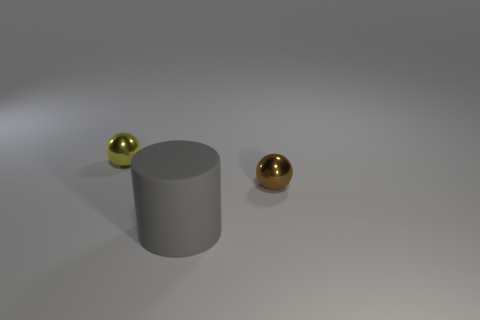There is a tiny thing that is behind the tiny brown metal sphere; what is its shape?
Give a very brief answer. Sphere. There is a tiny thing behind the tiny brown object; does it have the same shape as the large matte thing?
Your response must be concise. No. What number of things are either small things right of the yellow sphere or tiny matte cylinders?
Your response must be concise. 1. There is another tiny metal thing that is the same shape as the small yellow object; what is its color?
Keep it short and to the point. Brown. Are there any other things that have the same color as the big cylinder?
Give a very brief answer. No. There is a metal thing that is to the left of the small brown metal sphere; how big is it?
Provide a short and direct response. Small. Do the cylinder and the thing left of the cylinder have the same color?
Keep it short and to the point. No. What number of other objects are the same material as the brown sphere?
Keep it short and to the point. 1. Are there more tiny gray metal blocks than things?
Keep it short and to the point. No. Does the small ball that is behind the brown metal thing have the same color as the large matte thing?
Offer a very short reply. No. 